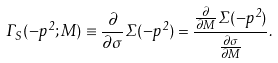<formula> <loc_0><loc_0><loc_500><loc_500>\Gamma _ { S } ( - p ^ { 2 } ; M ) \equiv \frac { \partial } { \partial \sigma } \Sigma ( - p ^ { 2 } ) = \frac { \frac { \partial } { \partial M } \Sigma ( - p ^ { 2 } ) } { \frac { \partial \sigma } { \partial M } } .</formula> 